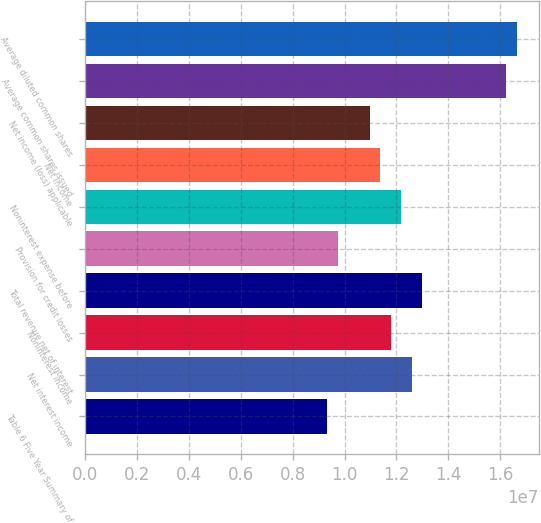Convert chart to OTSL. <chart><loc_0><loc_0><loc_500><loc_500><bar_chart><fcel>Table 6 Five Year Summary of<fcel>Net interest income<fcel>Noninterest income<fcel>Total revenue net of interest<fcel>Provision for credit losses<fcel>Noninterest expense before<fcel>Net income<fcel>Net income (loss) applicable<fcel>Average common shares issued<fcel>Average diluted common shares<nl><fcel>9.33882e+06<fcel>1.25871e+07<fcel>1.1775e+07<fcel>1.29931e+07<fcel>9.74486e+06<fcel>1.21811e+07<fcel>1.1369e+07<fcel>1.0963e+07<fcel>1.62414e+07<fcel>1.66475e+07<nl></chart> 